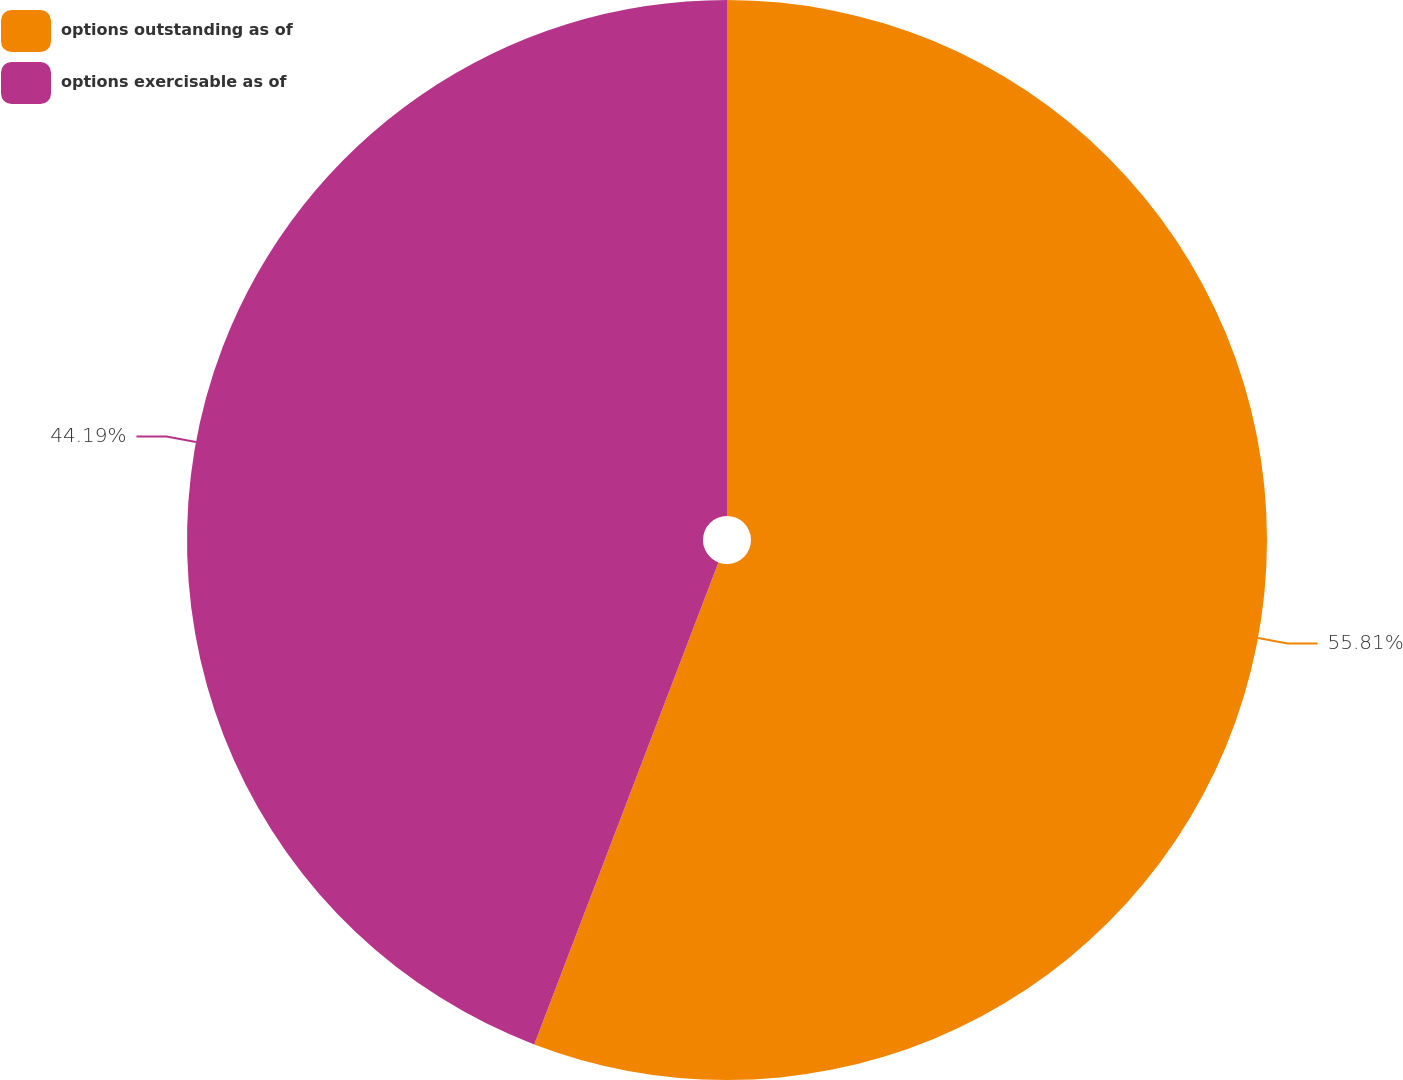<chart> <loc_0><loc_0><loc_500><loc_500><pie_chart><fcel>options outstanding as of<fcel>options exercisable as of<nl><fcel>55.81%<fcel>44.19%<nl></chart> 